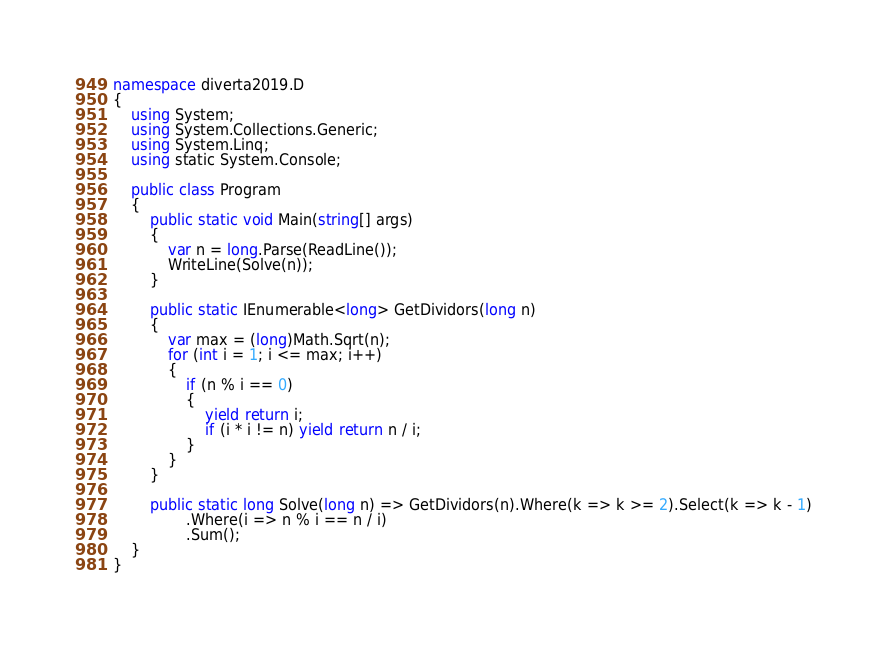Convert code to text. <code><loc_0><loc_0><loc_500><loc_500><_C#_>namespace diverta2019.D
{
    using System;
    using System.Collections.Generic;
    using System.Linq;
    using static System.Console;

    public class Program
    {
        public static void Main(string[] args)
        {
            var n = long.Parse(ReadLine());
            WriteLine(Solve(n));
        }

        public static IEnumerable<long> GetDividors(long n)
        {
            var max = (long)Math.Sqrt(n);
            for (int i = 1; i <= max; i++)
            {
                if (n % i == 0)
                {
                    yield return i;
                    if (i * i != n) yield return n / i;
                }
            }
        }

        public static long Solve(long n) => GetDividors(n).Where(k => k >= 2).Select(k => k - 1)
                .Where(i => n % i == n / i)
                .Sum();
    }
}</code> 